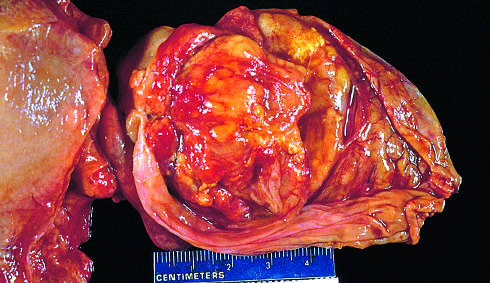what contains a large, exophytic tumor that virtually fills the lumen?
Answer the question using a single word or phrase. The opened gallbladder 